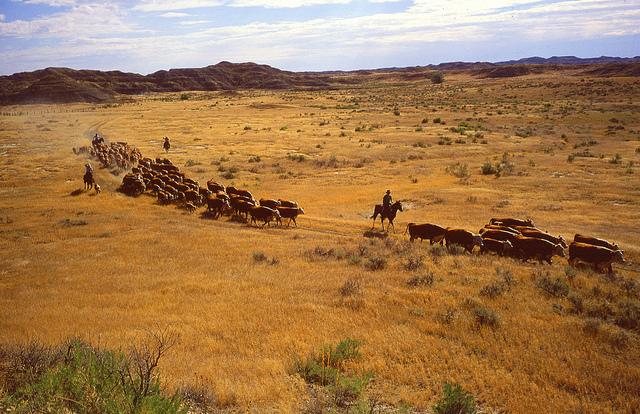What kind of cattle are these?
Write a very short answer. Cow. How many horses are there?
Give a very brief answer. 4. Are there mountains in this picture?
Short answer required. Yes. 